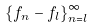Convert formula to latex. <formula><loc_0><loc_0><loc_500><loc_500>\{ f _ { n } - f _ { l } \} _ { n = l } ^ { \infty }</formula> 